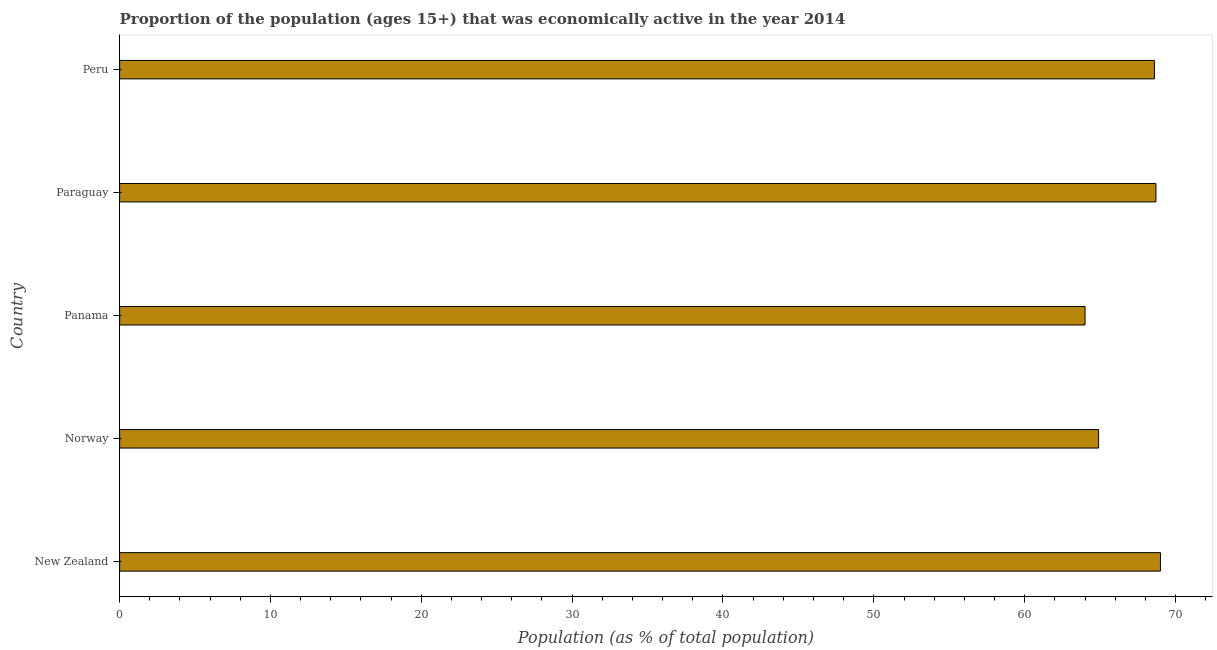Does the graph contain grids?
Provide a succinct answer. No. What is the title of the graph?
Your response must be concise. Proportion of the population (ages 15+) that was economically active in the year 2014. What is the label or title of the X-axis?
Provide a short and direct response. Population (as % of total population). What is the label or title of the Y-axis?
Keep it short and to the point. Country. What is the percentage of economically active population in Norway?
Keep it short and to the point. 64.9. Across all countries, what is the maximum percentage of economically active population?
Your answer should be compact. 69. In which country was the percentage of economically active population maximum?
Your answer should be compact. New Zealand. In which country was the percentage of economically active population minimum?
Ensure brevity in your answer.  Panama. What is the sum of the percentage of economically active population?
Keep it short and to the point. 335.2. What is the average percentage of economically active population per country?
Ensure brevity in your answer.  67.04. What is the median percentage of economically active population?
Make the answer very short. 68.6. What is the ratio of the percentage of economically active population in New Zealand to that in Panama?
Make the answer very short. 1.08. Is the percentage of economically active population in New Zealand less than that in Panama?
Ensure brevity in your answer.  No. Is the difference between the percentage of economically active population in New Zealand and Paraguay greater than the difference between any two countries?
Provide a short and direct response. No. In how many countries, is the percentage of economically active population greater than the average percentage of economically active population taken over all countries?
Give a very brief answer. 3. How many countries are there in the graph?
Ensure brevity in your answer.  5. What is the difference between two consecutive major ticks on the X-axis?
Offer a very short reply. 10. What is the Population (as % of total population) of New Zealand?
Give a very brief answer. 69. What is the Population (as % of total population) of Norway?
Your answer should be very brief. 64.9. What is the Population (as % of total population) of Paraguay?
Ensure brevity in your answer.  68.7. What is the Population (as % of total population) in Peru?
Provide a short and direct response. 68.6. What is the difference between the Population (as % of total population) in Norway and Panama?
Your response must be concise. 0.9. What is the difference between the Population (as % of total population) in Norway and Paraguay?
Make the answer very short. -3.8. What is the difference between the Population (as % of total population) in Panama and Paraguay?
Keep it short and to the point. -4.7. What is the ratio of the Population (as % of total population) in New Zealand to that in Norway?
Provide a succinct answer. 1.06. What is the ratio of the Population (as % of total population) in New Zealand to that in Panama?
Provide a succinct answer. 1.08. What is the ratio of the Population (as % of total population) in New Zealand to that in Paraguay?
Provide a short and direct response. 1. What is the ratio of the Population (as % of total population) in New Zealand to that in Peru?
Provide a short and direct response. 1.01. What is the ratio of the Population (as % of total population) in Norway to that in Panama?
Your response must be concise. 1.01. What is the ratio of the Population (as % of total population) in Norway to that in Paraguay?
Your answer should be very brief. 0.94. What is the ratio of the Population (as % of total population) in Norway to that in Peru?
Offer a very short reply. 0.95. What is the ratio of the Population (as % of total population) in Panama to that in Paraguay?
Your response must be concise. 0.93. What is the ratio of the Population (as % of total population) in Panama to that in Peru?
Keep it short and to the point. 0.93. 